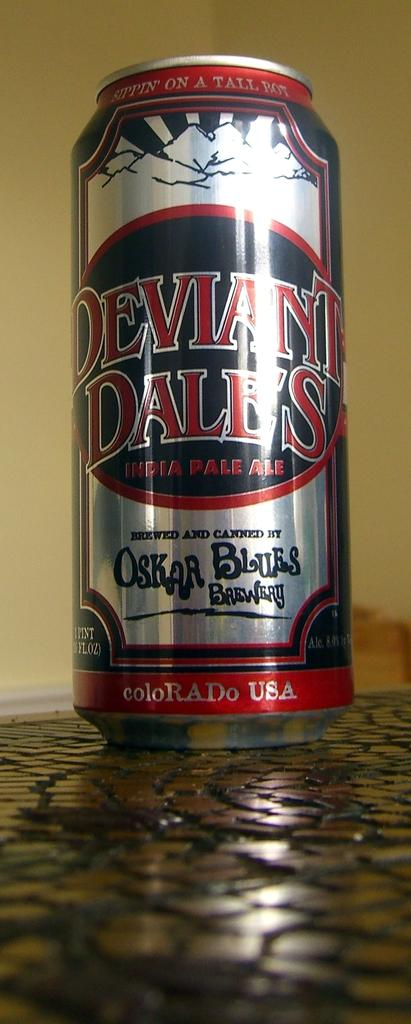<image>
Relay a brief, clear account of the picture shown. A tall can of Deviant Dale's India Pale Ale is sitting on a counter top.. 